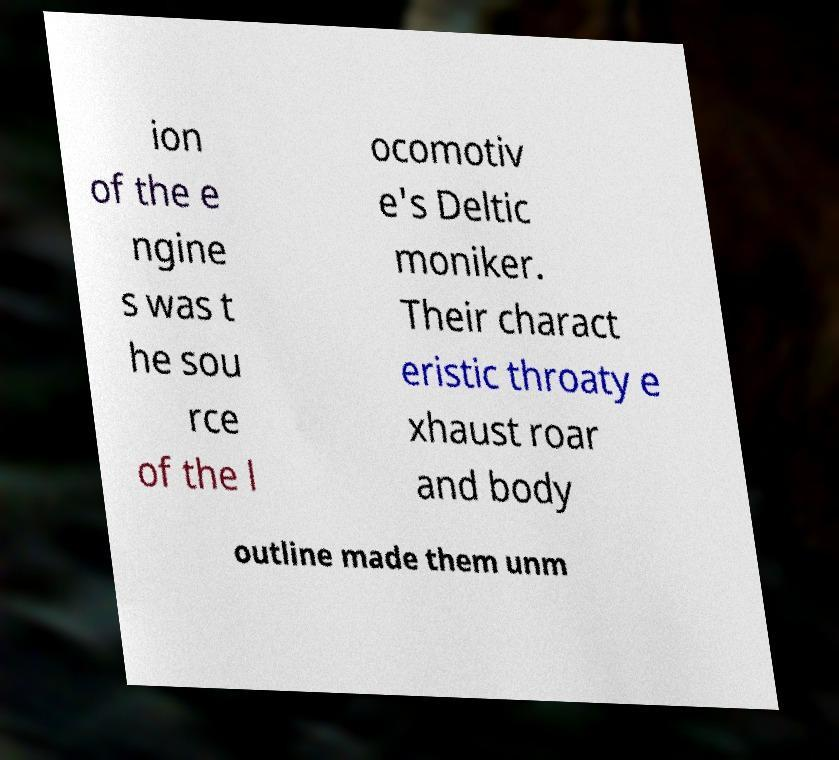For documentation purposes, I need the text within this image transcribed. Could you provide that? ion of the e ngine s was t he sou rce of the l ocomotiv e's Deltic moniker. Their charact eristic throaty e xhaust roar and body outline made them unm 